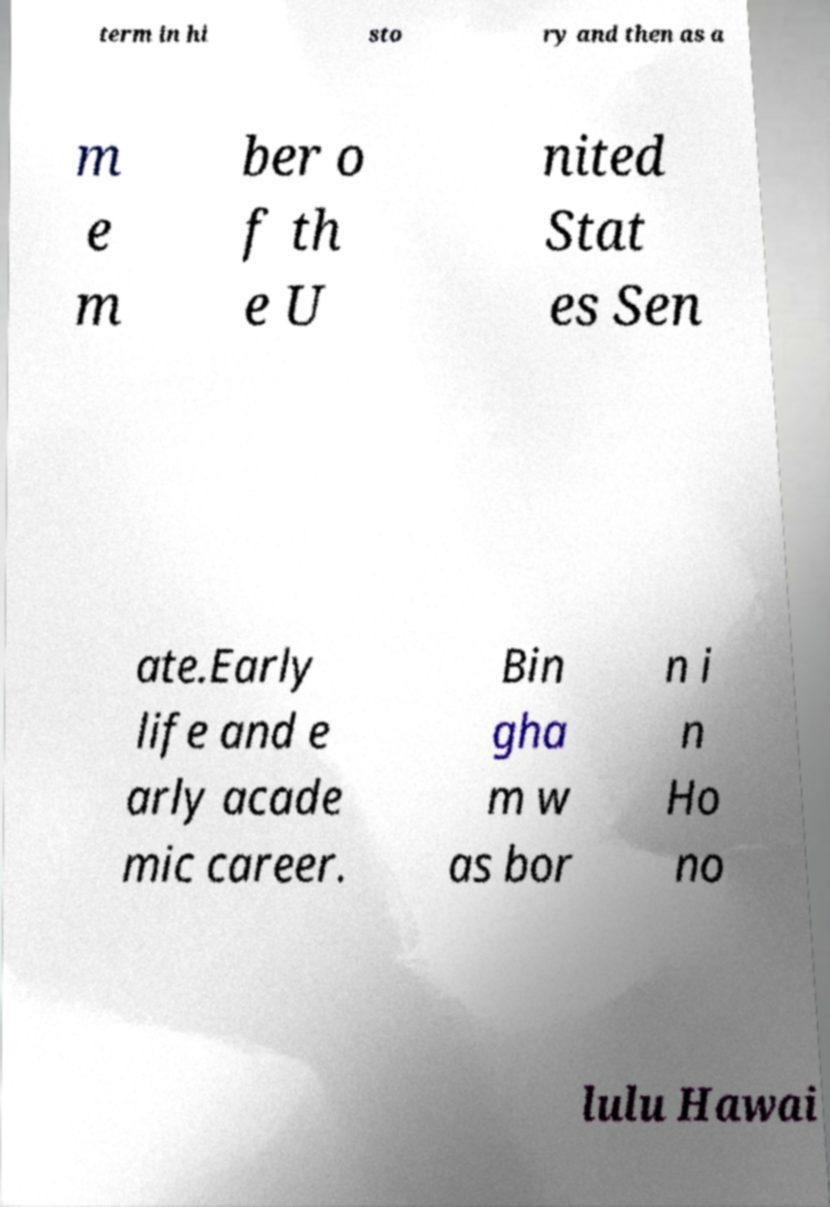For documentation purposes, I need the text within this image transcribed. Could you provide that? term in hi sto ry and then as a m e m ber o f th e U nited Stat es Sen ate.Early life and e arly acade mic career. Bin gha m w as bor n i n Ho no lulu Hawai 